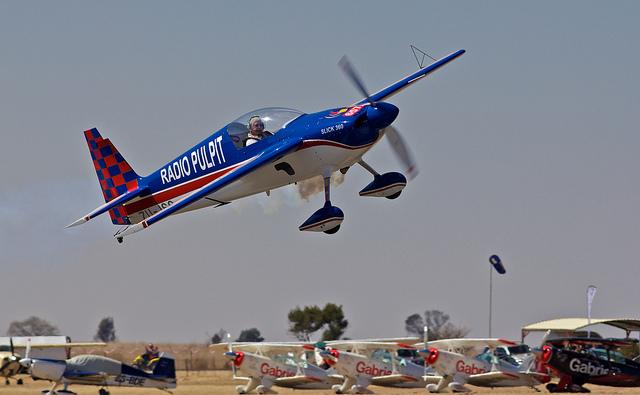Is the plane touching the ground?
Write a very short answer. No. Is there a pilot in the plane?
Be succinct. Yes. How many people are in the plane?
Be succinct. 1. Are the circles on the side a target?
Answer briefly. No. Which part of the plain contains the company name?
Be succinct. Side. What color is the propeller?
Keep it brief. Blue. Where is the plane?
Write a very short answer. In air. Are those propellers on the plane?
Concise answer only. Yes. 